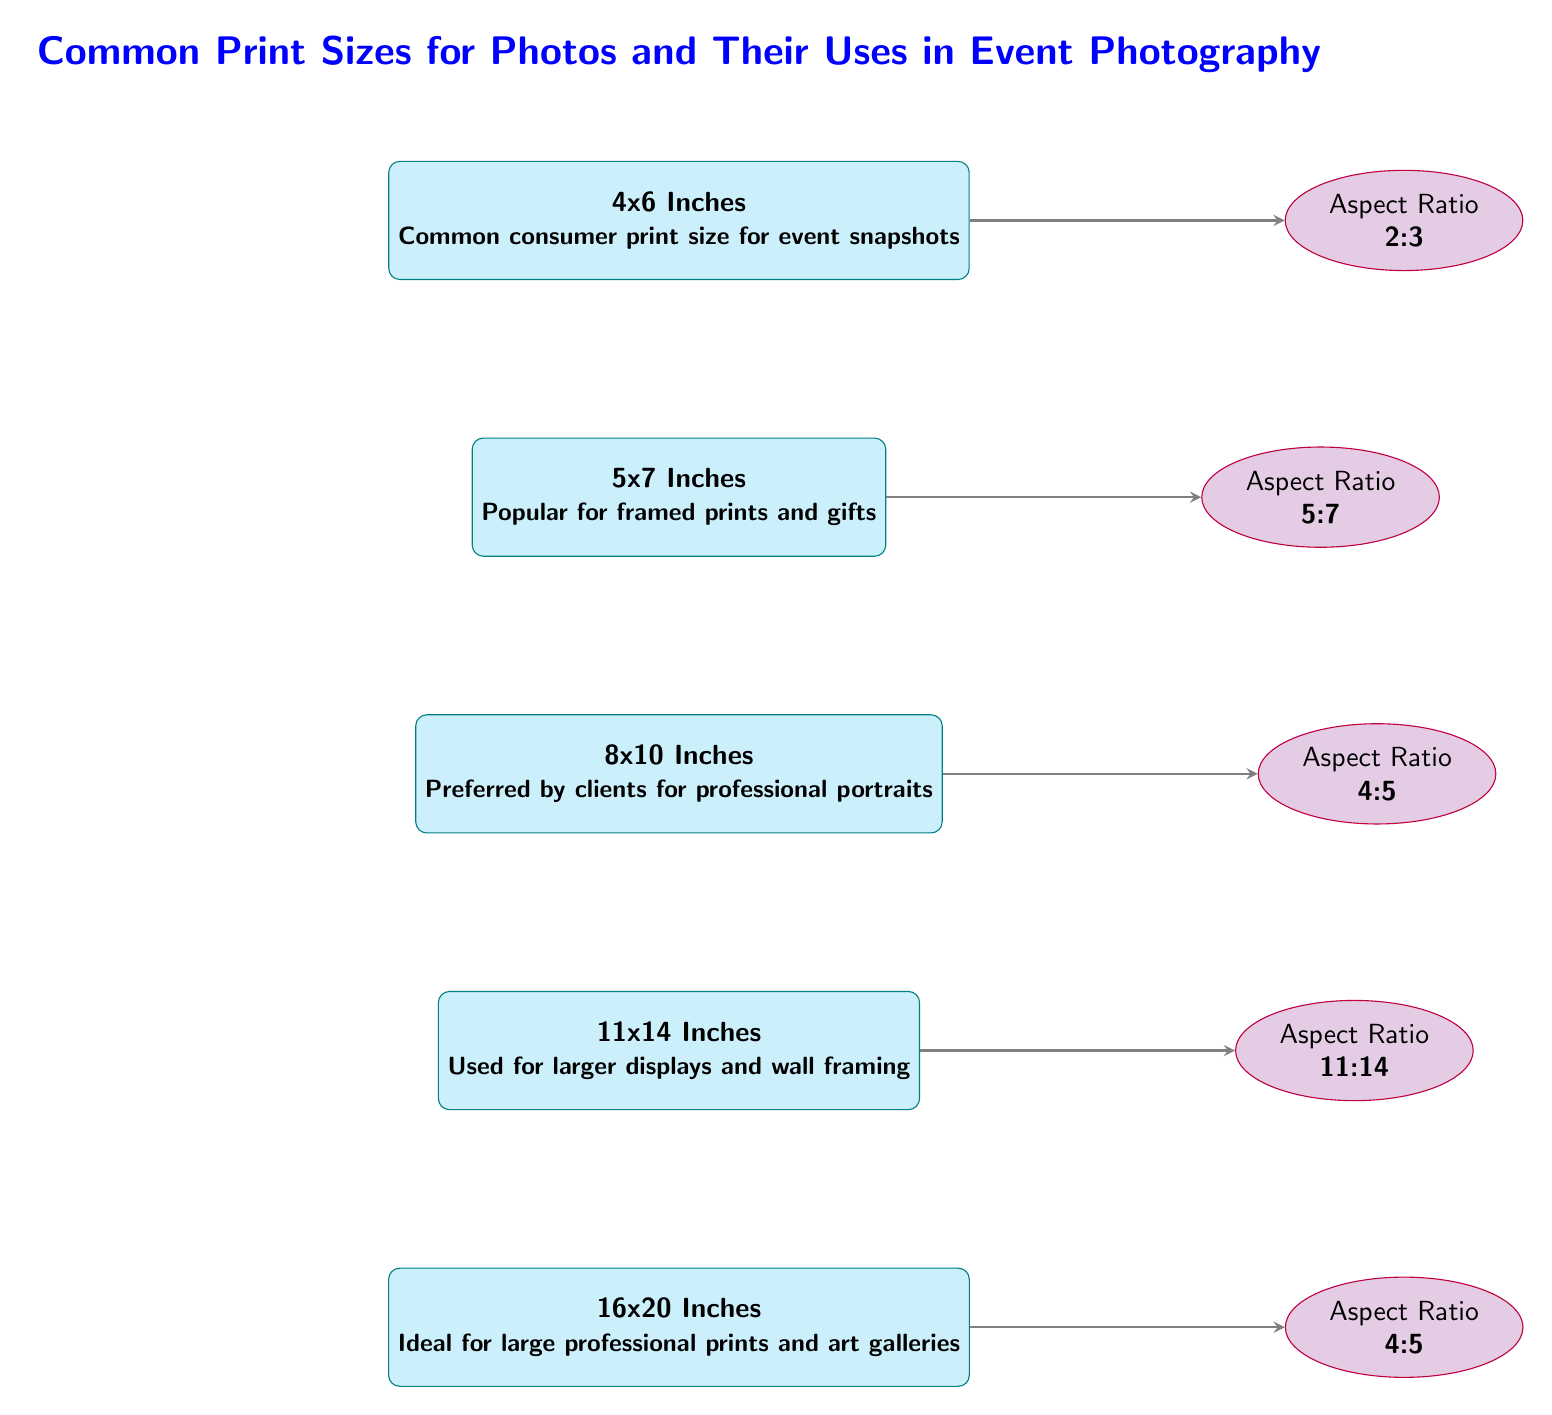What are the dimensions of the most common consumer print size? The diagram states that the most common consumer print size is 4x6 inches.
Answer: 4x6 Inches Which print size is preferred by clients for professional portraits? According to the diagram, the print size that is preferred by clients for professional portraits is 8x10 inches.
Answer: 8x10 Inches What is the aspect ratio of the 5x7 inches print size? The diagram shows that the aspect ratio corresponding to the 5x7 inches print size is 5:7.
Answer: 5:7 How many print sizes are listed in the diagram? By counting the nodes representing photo sizes, there are five print sizes shown in the diagram.
Answer: 5 For which print size is the aspect ratio listed as 4:5? The diagram lists the aspect ratio of 4:5 for two print sizes: 8x10 inches and 16x20 inches.
Answer: 8x10 Inches and 16x20 Inches What type of print is ideal for large professional prints and art galleries? The diagram indicates that the 16x20 inches print size is ideal for large professional prints and art galleries.
Answer: 16x20 Inches Which print size is commonly used for larger displays? The diagram states that the 11x14 inches print size is used for larger displays and wall framing.
Answer: 11x14 Inches Why might someone choose the 5x7 inches print size? The diagram mentions that the 5x7 inches print size is popular for framed prints and gifts, indicating its versatility for those purposes.
Answer: Popular for framed prints and gifts What do the arrows in the diagram represent? The arrows in the diagram point from each print size to its corresponding aspect ratio, illustrating the relationship between photo dimensions and their aspect ratios.
Answer: Relationship between sizes and aspect ratios 